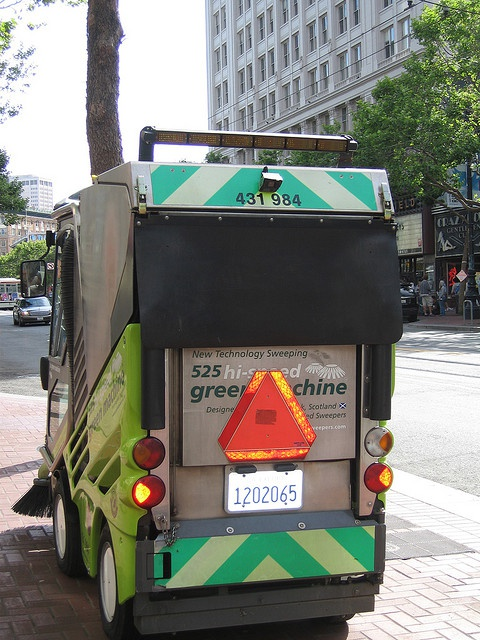Describe the objects in this image and their specific colors. I can see truck in white, black, and gray tones, car in white, black, gray, and lightgray tones, car in white, black, gray, and darkgray tones, people in white, gray, and black tones, and people in white, black, gray, navy, and darkblue tones in this image. 